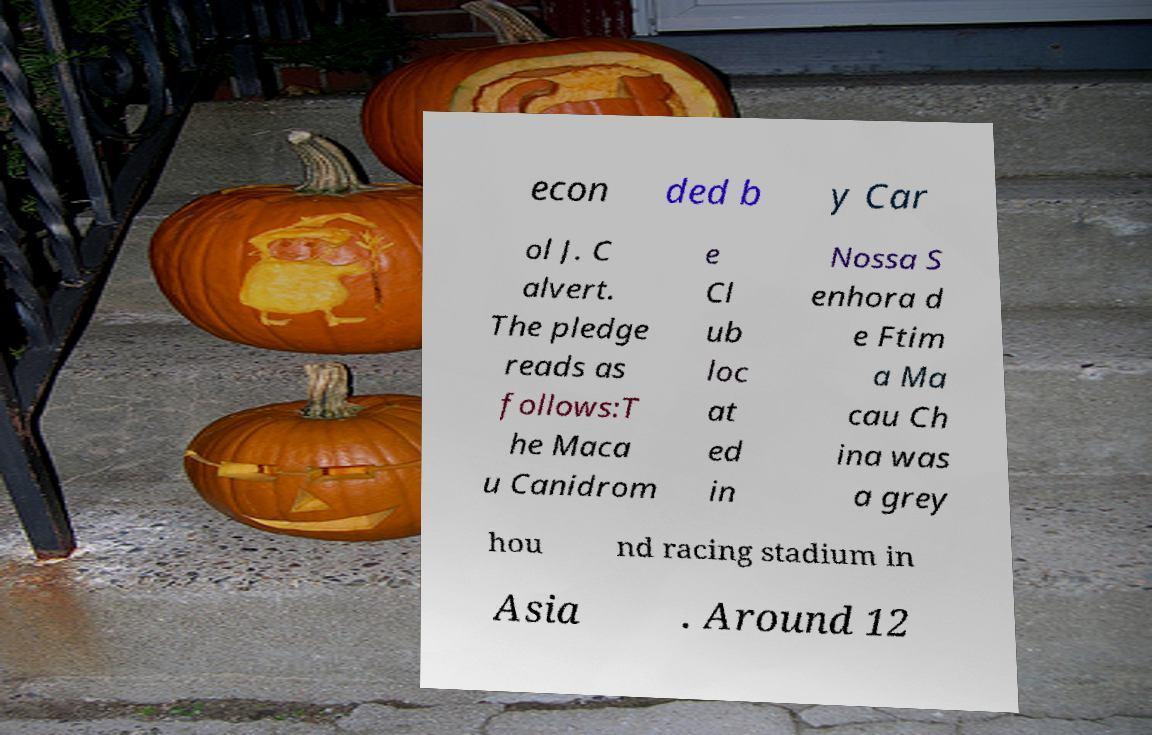I need the written content from this picture converted into text. Can you do that? econ ded b y Car ol J. C alvert. The pledge reads as follows:T he Maca u Canidrom e Cl ub loc at ed in Nossa S enhora d e Ftim a Ma cau Ch ina was a grey hou nd racing stadium in Asia . Around 12 